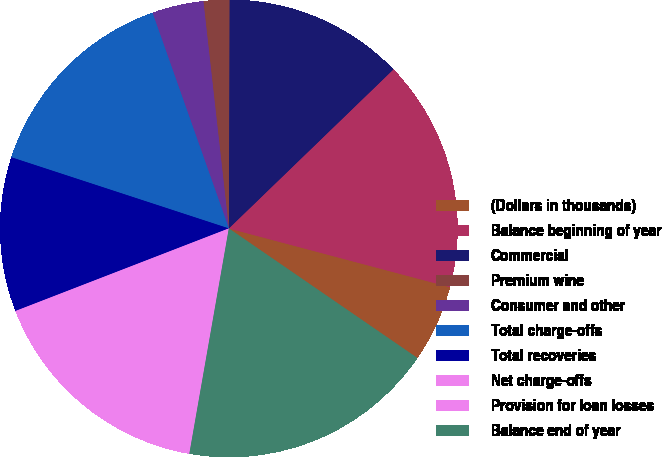Convert chart to OTSL. <chart><loc_0><loc_0><loc_500><loc_500><pie_chart><fcel>(Dollars in thousands)<fcel>Balance beginning of year<fcel>Commercial<fcel>Premium wine<fcel>Consumer and other<fcel>Total charge-offs<fcel>Total recoveries<fcel>Net charge-offs<fcel>Provision for loan losses<fcel>Balance end of year<nl><fcel>5.45%<fcel>16.36%<fcel>12.73%<fcel>1.82%<fcel>3.64%<fcel>14.55%<fcel>10.91%<fcel>7.27%<fcel>9.09%<fcel>18.18%<nl></chart> 